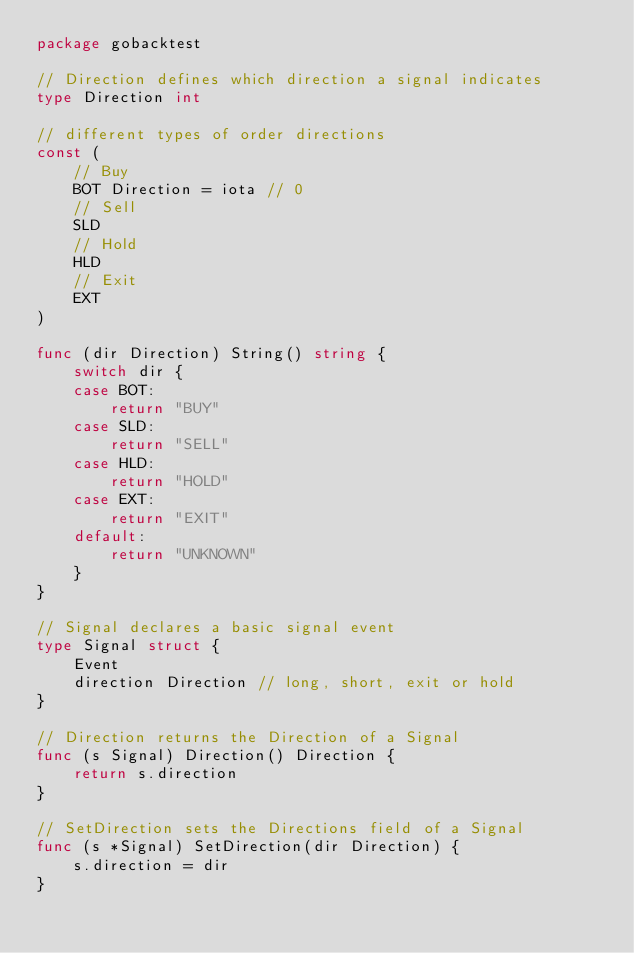<code> <loc_0><loc_0><loc_500><loc_500><_Go_>package gobacktest

// Direction defines which direction a signal indicates
type Direction int

// different types of order directions
const (
	// Buy
	BOT Direction = iota // 0
	// Sell
	SLD
	// Hold
	HLD
	// Exit
	EXT
)

func (dir Direction) String() string {
	switch dir {
	case BOT:
		return "BUY"
	case SLD:
		return "SELL"
	case HLD:
		return "HOLD"
	case EXT:
		return "EXIT"
	default:
		return "UNKNOWN"
	}
}

// Signal declares a basic signal event
type Signal struct {
	Event
	direction Direction // long, short, exit or hold
}

// Direction returns the Direction of a Signal
func (s Signal) Direction() Direction {
	return s.direction
}

// SetDirection sets the Directions field of a Signal
func (s *Signal) SetDirection(dir Direction) {
	s.direction = dir
}
</code> 